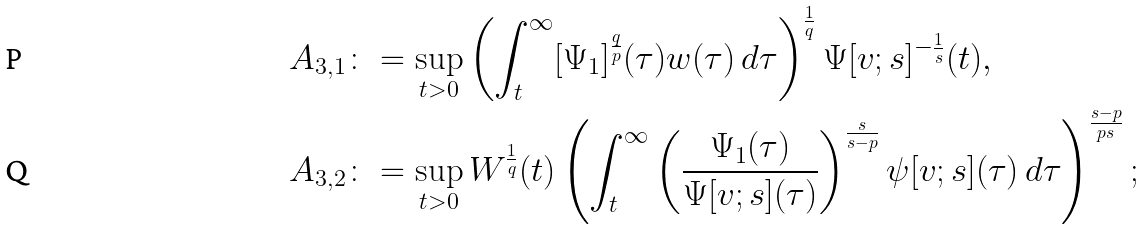<formula> <loc_0><loc_0><loc_500><loc_500>A _ { 3 , 1 } \colon & = \sup _ { t > 0 } \left ( \int _ { t } ^ { \infty } [ \Psi _ { 1 } ] ^ { \frac { q } { p } } ( \tau ) w ( \tau ) \, d \tau \right ) ^ { \frac { 1 } { q } } \Psi [ v ; s ] ^ { - \frac { 1 } { s } } ( t ) , \\ A _ { 3 , 2 } \colon & = \sup _ { t > 0 } W ^ { \frac { 1 } { q } } ( t ) \left ( \int _ { t } ^ { \infty } \left ( \frac { \Psi _ { 1 } ( \tau ) } { \Psi [ v ; s ] ( \tau ) } \right ) ^ { \frac { s } { s - p } } \psi [ v ; s ] ( \tau ) \, d \tau \right ) ^ { \frac { s - p } { p s } } ;</formula> 